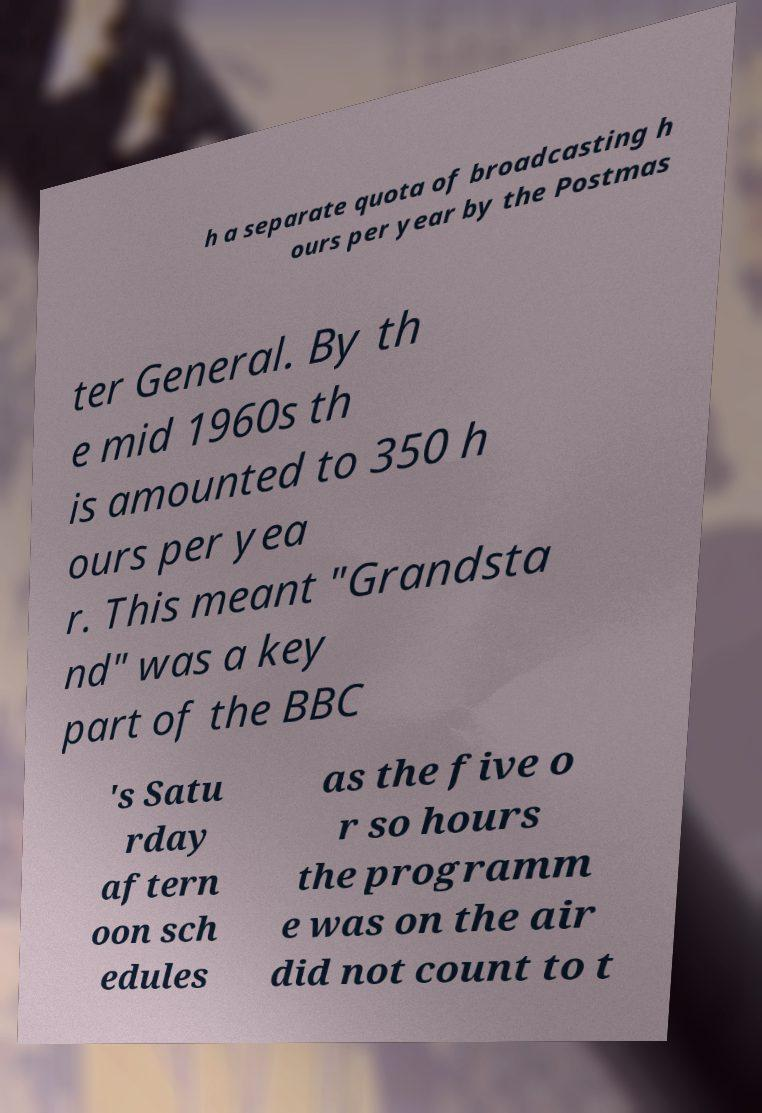For documentation purposes, I need the text within this image transcribed. Could you provide that? h a separate quota of broadcasting h ours per year by the Postmas ter General. By th e mid 1960s th is amounted to 350 h ours per yea r. This meant "Grandsta nd" was a key part of the BBC 's Satu rday aftern oon sch edules as the five o r so hours the programm e was on the air did not count to t 